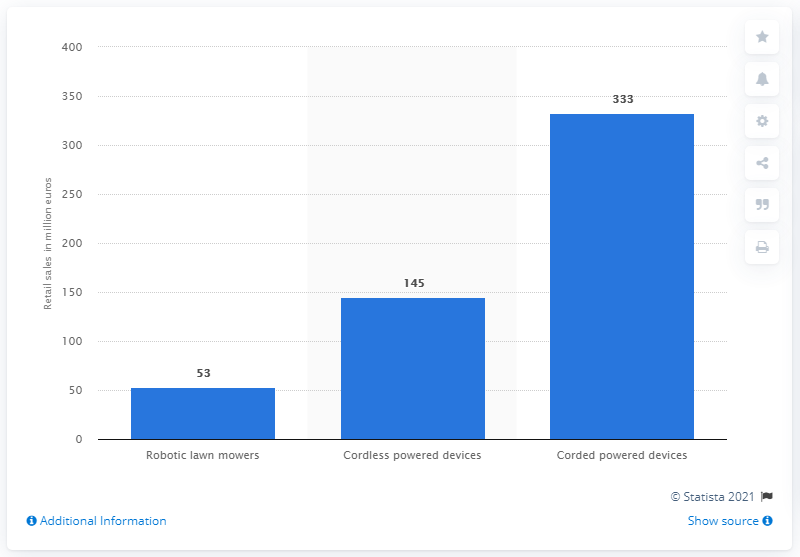List a handful of essential elements in this visual. According to sales data for the first half of 2014, robotic lawn mowers generated approximately $53 million in revenue. According to data from the first six months of 2014, cordless mowers generated a significant amount in sales. Specifically, the sales figures were 333... 